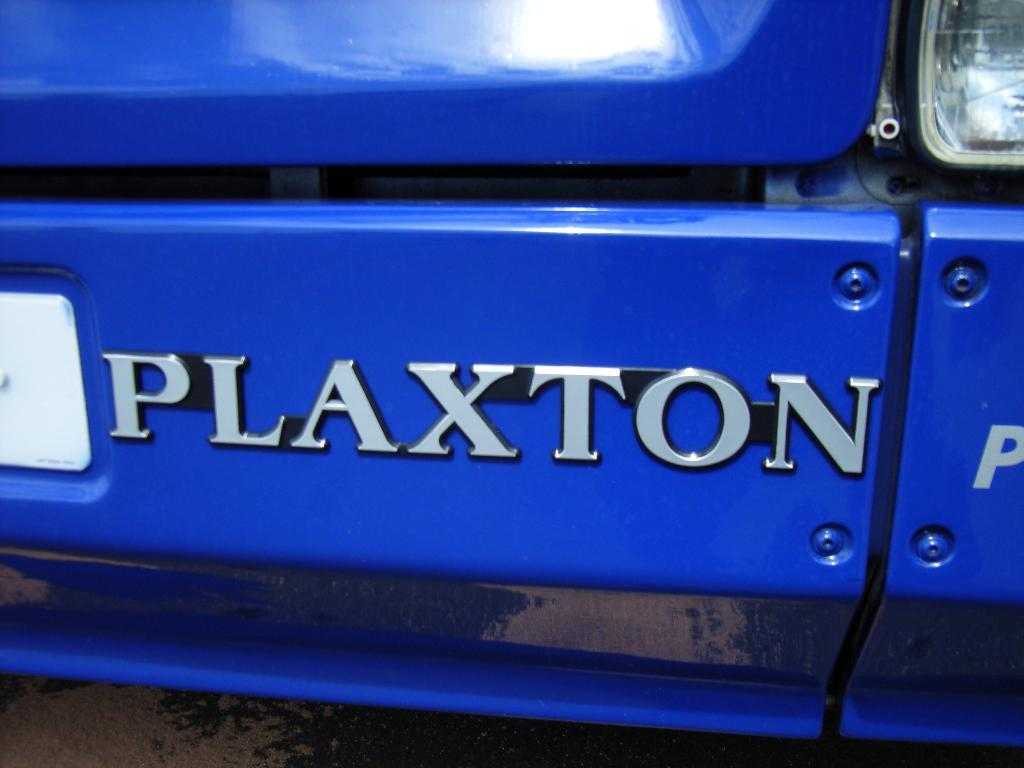What type of object is the main subject in the image? There is a vehicle in the image. What color is the vehicle? The vehicle has a blue color. Are there any markings or text on the vehicle? Yes, there is silver color text on the vehicle. What other features can be seen on the vehicle? The vehicle has a light and a white color number plate. On what surface is the vehicle placed? The vehicle is on a surface. How many legs does the turkey have in the image? There is no turkey present in the image. What type of music is playing in the background of the image? There is no music or sound present in the image. 